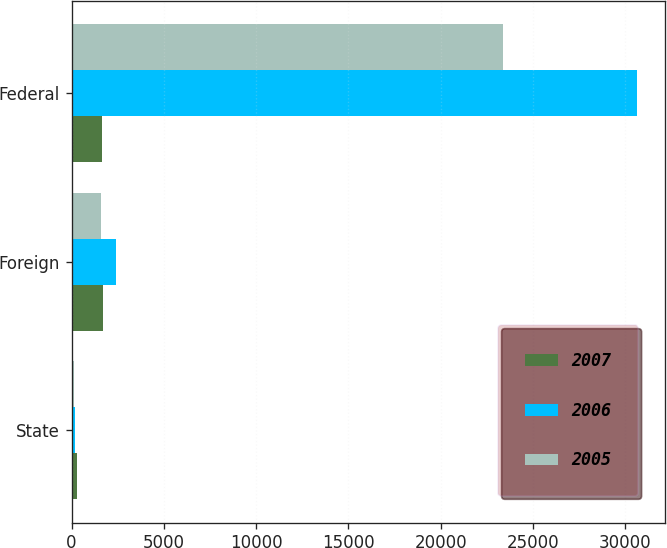Convert chart to OTSL. <chart><loc_0><loc_0><loc_500><loc_500><stacked_bar_chart><ecel><fcel>State<fcel>Foreign<fcel>Federal<nl><fcel>2007<fcel>292<fcel>1685<fcel>1628<nl><fcel>2006<fcel>203<fcel>2383<fcel>30624<nl><fcel>2005<fcel>132<fcel>1571<fcel>23405<nl></chart> 